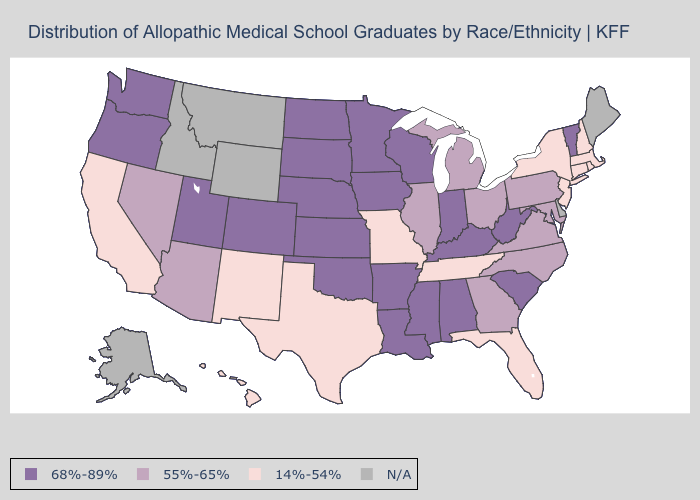What is the value of Wyoming?
Quick response, please. N/A. How many symbols are there in the legend?
Give a very brief answer. 4. What is the lowest value in the MidWest?
Quick response, please. 14%-54%. Does the first symbol in the legend represent the smallest category?
Short answer required. No. Which states hav the highest value in the Northeast?
Answer briefly. Vermont. What is the value of Oklahoma?
Be succinct. 68%-89%. Name the states that have a value in the range 14%-54%?
Keep it brief. California, Connecticut, Florida, Hawaii, Massachusetts, Missouri, New Hampshire, New Jersey, New Mexico, New York, Rhode Island, Tennessee, Texas. Which states have the highest value in the USA?
Concise answer only. Alabama, Arkansas, Colorado, Indiana, Iowa, Kansas, Kentucky, Louisiana, Minnesota, Mississippi, Nebraska, North Dakota, Oklahoma, Oregon, South Carolina, South Dakota, Utah, Vermont, Washington, West Virginia, Wisconsin. What is the value of Utah?
Write a very short answer. 68%-89%. Among the states that border North Carolina , which have the highest value?
Concise answer only. South Carolina. What is the lowest value in the South?
Keep it brief. 14%-54%. How many symbols are there in the legend?
Answer briefly. 4. Name the states that have a value in the range 14%-54%?
Be succinct. California, Connecticut, Florida, Hawaii, Massachusetts, Missouri, New Hampshire, New Jersey, New Mexico, New York, Rhode Island, Tennessee, Texas. 